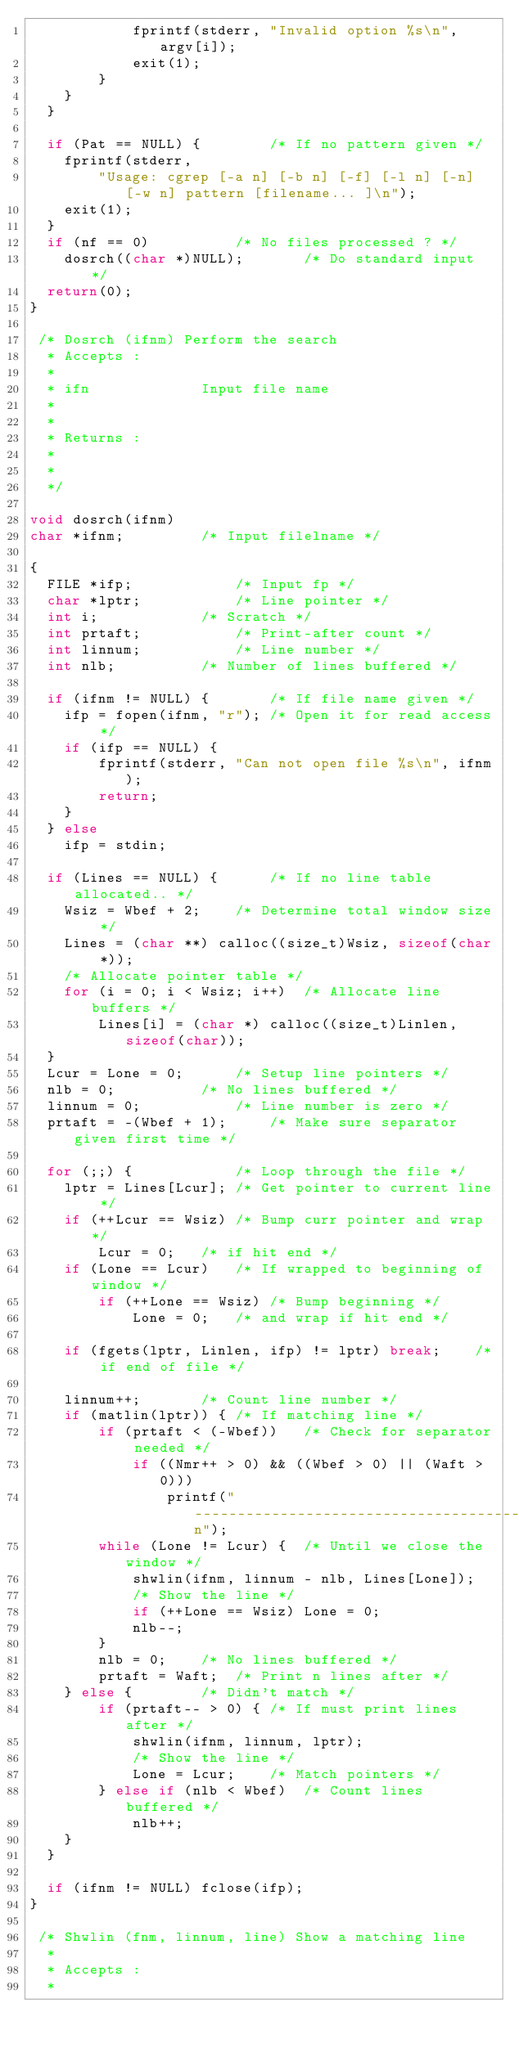<code> <loc_0><loc_0><loc_500><loc_500><_C_>			fprintf(stderr, "Invalid option %s\n", argv[i]);
			exit(1);
		}
	}
  }

  if (Pat == NULL) {		/* If no pattern given */
	fprintf(stderr,
		"Usage: cgrep [-a n] [-b n] [-f] [-l n] [-n] [-w n] pattern [filename... ]\n");
	exit(1);
  }
  if (nf == 0)			/* No files processed ? */
	dosrch((char *)NULL);		/* Do standard input */
  return(0);
}

 /* Dosrch (ifnm) Perform the search 
  * Accepts :
  * 
  * ifn             Input file name
  * 
  * 
  * Returns :
  * 
  * 
  */

void dosrch(ifnm)
char *ifnm;			/* Input filelname */

{
  FILE *ifp;			/* Input fp */
  char *lptr;			/* Line pointer */
  int i;			/* Scratch */
  int prtaft;			/* Print-after count */
  int linnum;			/* Line number */
  int nlb;			/* Number of lines buffered */

  if (ifnm != NULL) {		/* If file name given */
	ifp = fopen(ifnm, "r");	/* Open it for read access */
	if (ifp == NULL) {
		fprintf(stderr, "Can not open file %s\n", ifnm);
		return;
	}
  } else
	ifp = stdin;

  if (Lines == NULL) {		/* If no line table allocated.. */
	Wsiz = Wbef + 2;	/* Determine total window size */
	Lines = (char **) calloc((size_t)Wsiz, sizeof(char *));
	/* Allocate pointer table */
	for (i = 0; i < Wsiz; i++)	/* Allocate line buffers */
		Lines[i] = (char *) calloc((size_t)Linlen, sizeof(char));
  }
  Lcur = Lone = 0;		/* Setup line pointers */
  nlb = 0;			/* No lines buffered */
  linnum = 0;			/* Line number is zero */
  prtaft = -(Wbef + 1);		/* Make sure separator given first time */

  for (;;) {			/* Loop through the file */
	lptr = Lines[Lcur];	/* Get pointer to current line */
	if (++Lcur == Wsiz)	/* Bump curr pointer and wrap */
		Lcur = 0;	/* if hit end */
	if (Lone == Lcur)	/* If wrapped to beginning of window */
		if (++Lone == Wsiz)	/* Bump beginning */
			Lone = 0;	/* and wrap if hit end */

	if (fgets(lptr, Linlen, ifp) != lptr) break;	/* if end of file */

	linnum++;		/* Count line number */
	if (matlin(lptr)) {	/* If matching line */
		if (prtaft < (-Wbef))	/* Check for separator needed */
			if ((Nmr++ > 0) && ((Wbef > 0) || (Waft > 0)))
				printf("----------------------------------------------------------------------------\n");
		while (Lone != Lcur) {	/* Until we close the window */
			shwlin(ifnm, linnum - nlb, Lines[Lone]);
			/* Show the line */
			if (++Lone == Wsiz) Lone = 0;
			nlb--;
		}
		nlb = 0;	/* No lines buffered */
		prtaft = Waft;	/* Print n lines after */
	} else {		/* Didn't match */
		if (prtaft-- > 0) {	/* If must print lines after */
			shwlin(ifnm, linnum, lptr);
			/* Show the line */
			Lone = Lcur;	/* Match pointers */
		} else if (nlb < Wbef)	/* Count lines buffered */
			nlb++;
	}
  }

  if (ifnm != NULL) fclose(ifp);
}

 /* Shwlin (fnm, linnum, line) Show a matching line 
  * 
  * Accepts :
  * </code> 